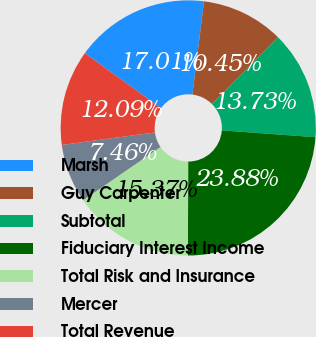Convert chart to OTSL. <chart><loc_0><loc_0><loc_500><loc_500><pie_chart><fcel>Marsh<fcel>Guy Carpenter<fcel>Subtotal<fcel>Fiduciary Interest Income<fcel>Total Risk and Insurance<fcel>Mercer<fcel>Total Revenue<nl><fcel>17.01%<fcel>10.45%<fcel>13.73%<fcel>23.88%<fcel>15.37%<fcel>7.46%<fcel>12.09%<nl></chart> 